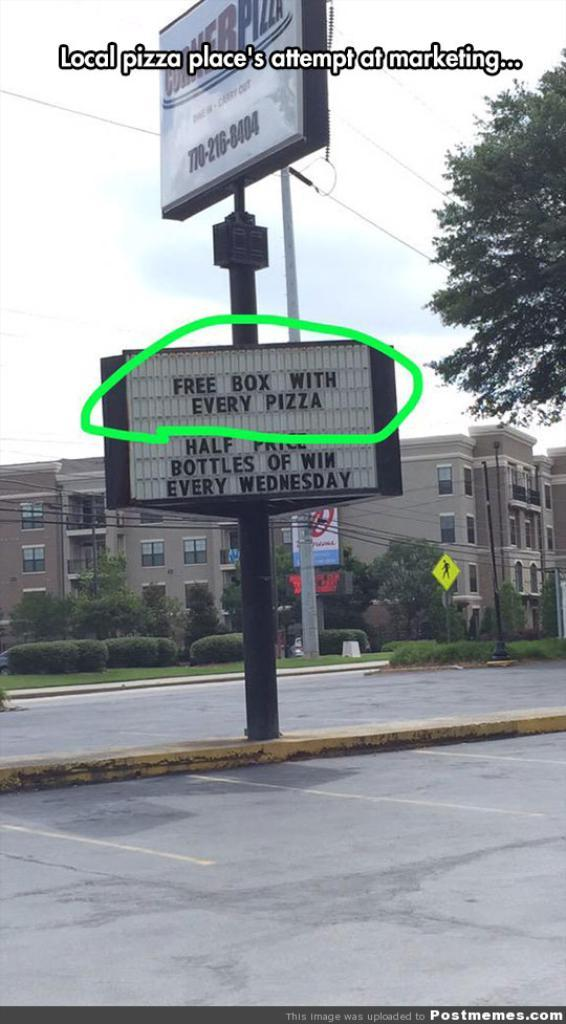<image>
Summarize the visual content of the image. the words every Wednesday are on the sign for pizza 